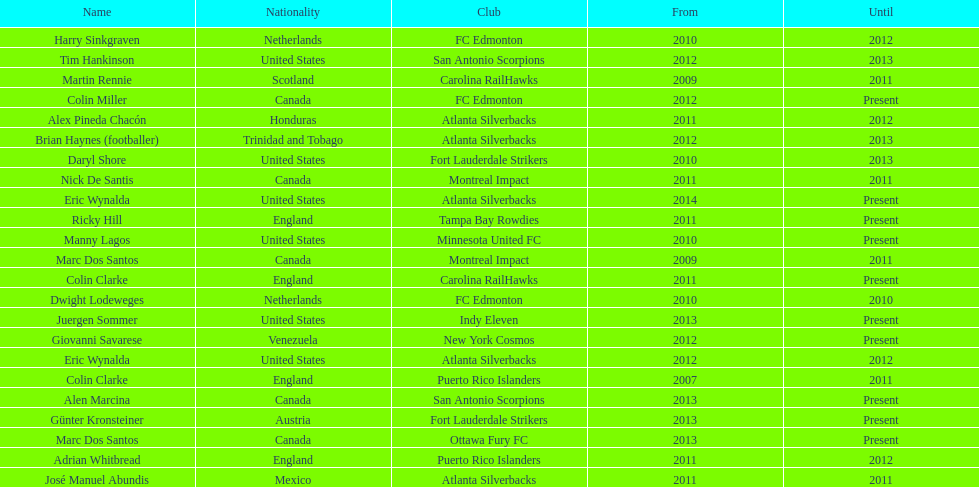What same country did marc dos santos coach as colin miller? Canada. 